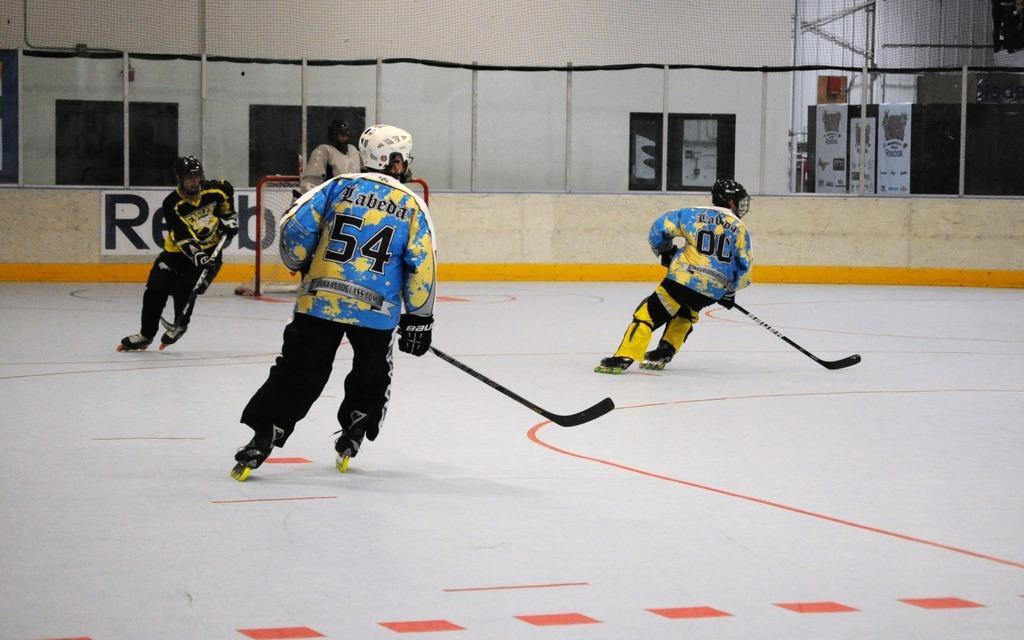In one or two sentences, can you explain what this image depicts? In this image I see 4 persons who are wearing jerseys and I see that these 3 are holding sticks in their hands and I see all of them are wearing helmets and I see the white ice on which there are red color lines. In the background I see the fencing and the wall over here and I see few alphabets over here. 